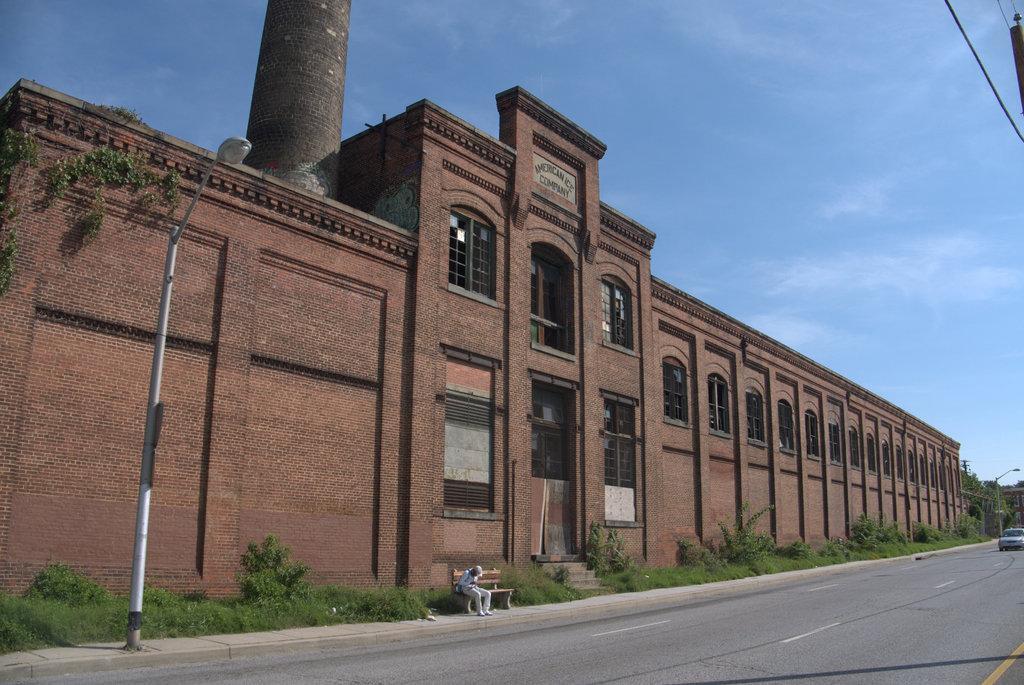Please provide a concise description of this image. This picture is clicked outside the city. At the bottom of the picture, we see the road. In the middle of the picture, we see a person in the white shirt is sitting on the bench. Beside that, we see grass and shrubs. In front of the picture, we see a light pole. On the right side, we see a car is moving on the road and beside that, we see a light pole. In the background, we see a building in brown color. It has doors and windows. Beside the bench, we see a staircase. At the top of the picture, we see the sky. 